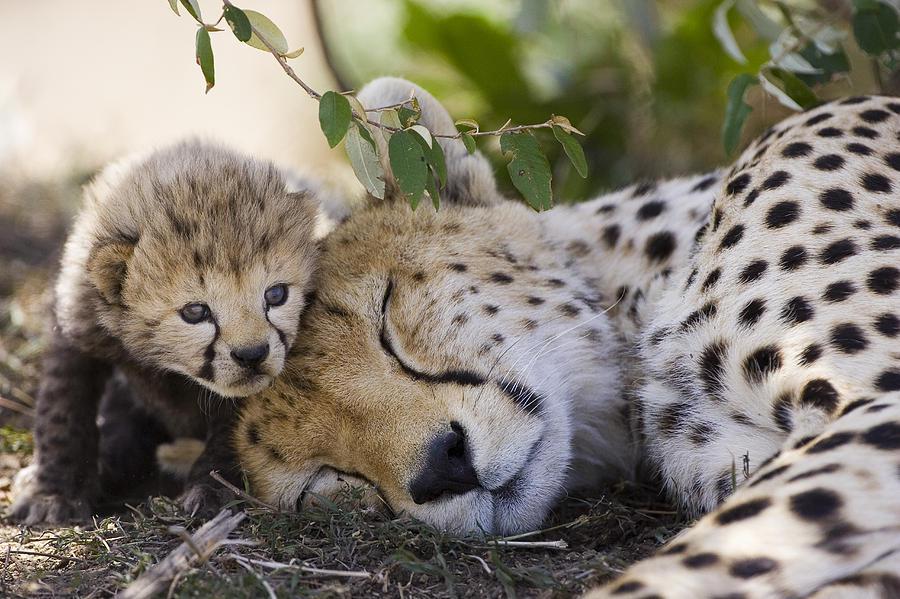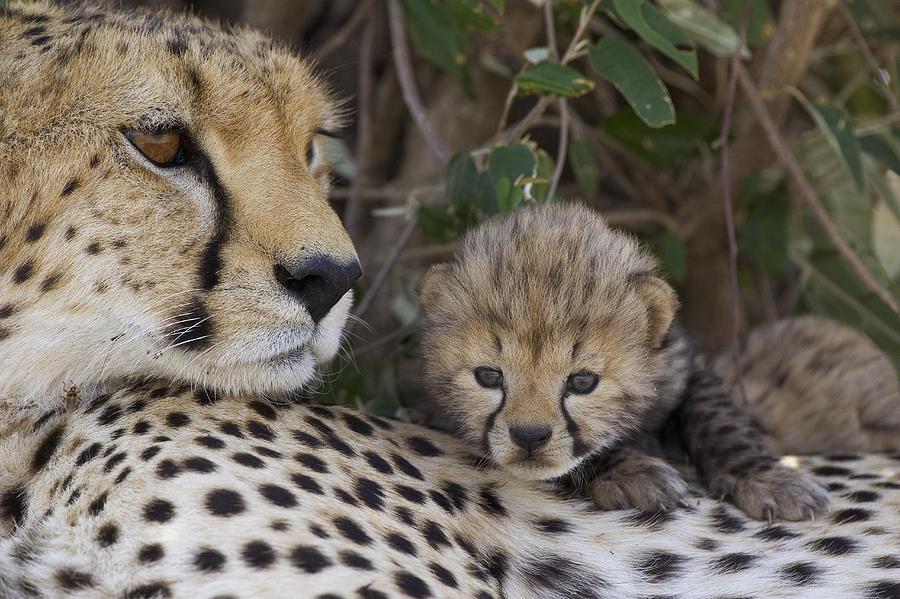The first image is the image on the left, the second image is the image on the right. Evaluate the accuracy of this statement regarding the images: "A baby leopard is laying next to its mom.". Is it true? Answer yes or no. Yes. The first image is the image on the left, the second image is the image on the right. Analyze the images presented: Is the assertion "In the image to the right, a cheetah kitten is laying down, looking forwards." valid? Answer yes or no. Yes. 